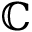Convert formula to latex. <formula><loc_0><loc_0><loc_500><loc_500>\mathbb { C }</formula> 